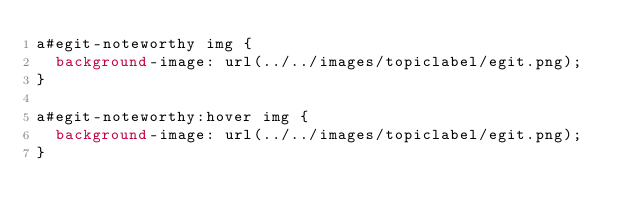Convert code to text. <code><loc_0><loc_0><loc_500><loc_500><_CSS_>a#egit-noteworthy img {
	background-image: url(../../images/topiclabel/egit.png);
}

a#egit-noteworthy:hover img {
	background-image: url(../../images/topiclabel/egit.png);
}</code> 